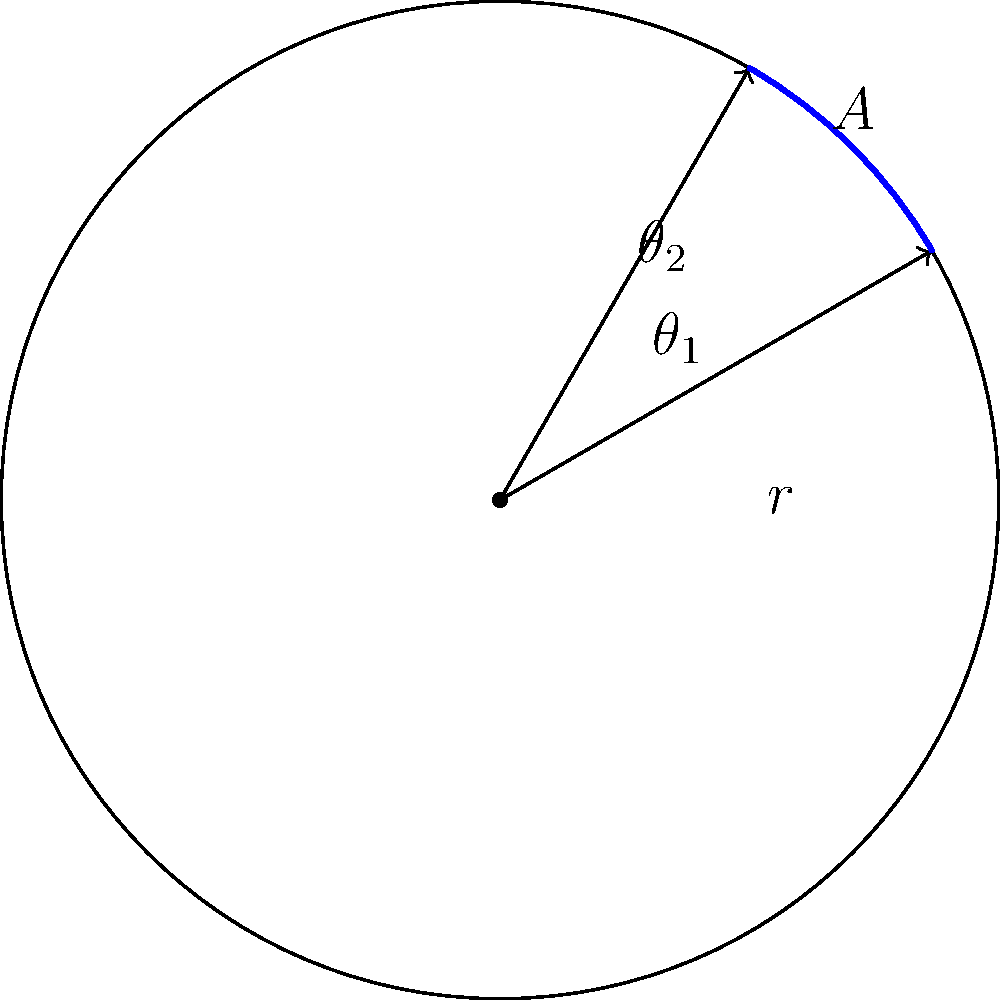A circular sprinkler system with a radius of 30 meters is being used to irrigate a section of your farm. The sprinkler rotates from $\theta_1 = 30°$ to $\theta_2 = 60°$ (measured counterclockwise from the positive x-axis). What is the area of the irrigated sector in square meters? Round your answer to the nearest whole number. To solve this problem, we'll use the formula for the area of a sector in polar coordinates:

$A = \frac{1}{2}r^2(\theta_2 - \theta_1)$

Where:
- $r$ is the radius of the circle (sprinkler range)
- $\theta_2 - \theta_1$ is the central angle in radians

Step 1: Convert the given angles from degrees to radians:
$\theta_1 = 30° = \frac{\pi}{6}$ radians
$\theta_2 = 60° = \frac{\pi}{3}$ radians

Step 2: Calculate the difference between the angles:
$\theta_2 - \theta_1 = \frac{\pi}{3} - \frac{\pi}{6} = \frac{\pi}{6}$ radians

Step 3: Apply the formula:
$A = \frac{1}{2}r^2(\theta_2 - \theta_1)$
$A = \frac{1}{2}(30\text{ m})^2(\frac{\pi}{6})$
$A = \frac{1}{2}(900\text{ m}^2)(\frac{\pi}{6})$
$A = 150\pi \text{ m}^2$

Step 4: Calculate and round to the nearest whole number:
$A \approx 471 \text{ m}^2$
Answer: 471 m² 